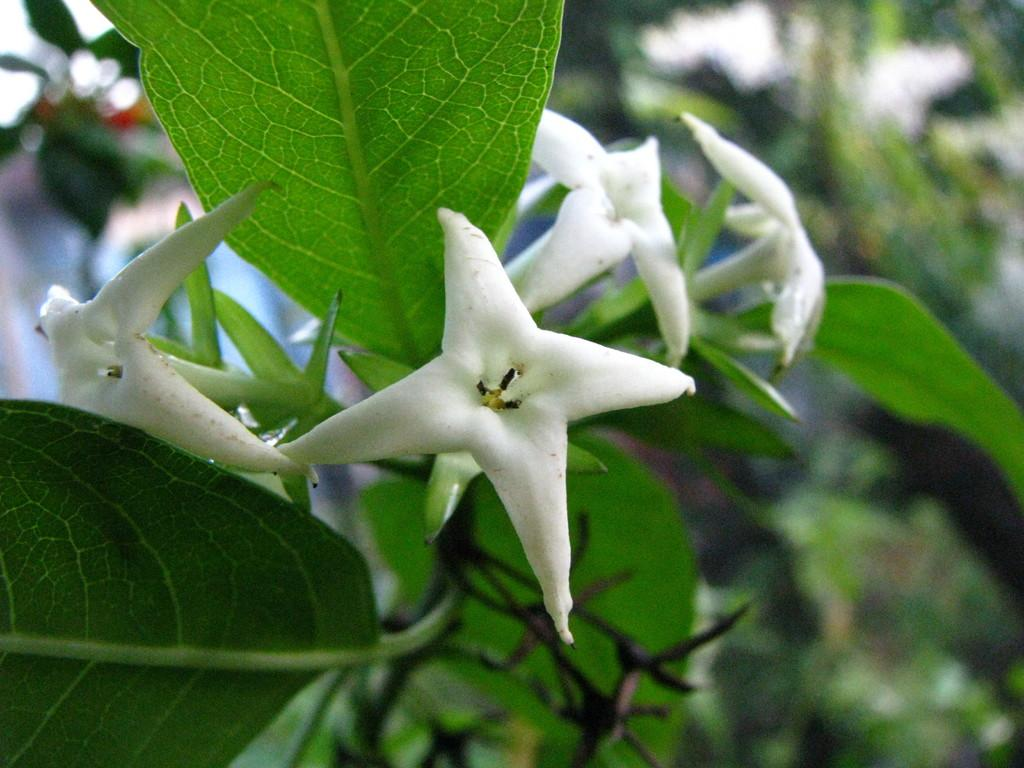What is the main subject of the picture? The main subject of the picture is a plant. What color are the flowers on the plant? The flowers on the plant are white. Can you describe the background of the image? The background of the image is blurred. How does the zephyr affect the plant in the image? There is no mention of a zephyr or any wind in the image, so it cannot be determined how it would affect the plant. What type of lip can be seen on the plant in the image? There are no lips present in the image; it features a plant with white flowers. 